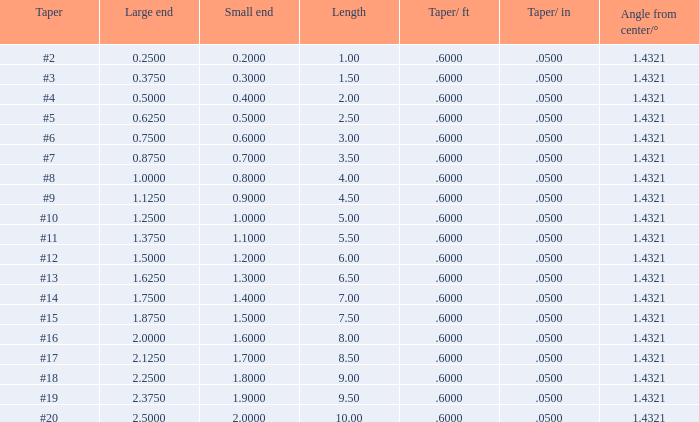What length possesses a taper of #15, and a large end exceeding None. 